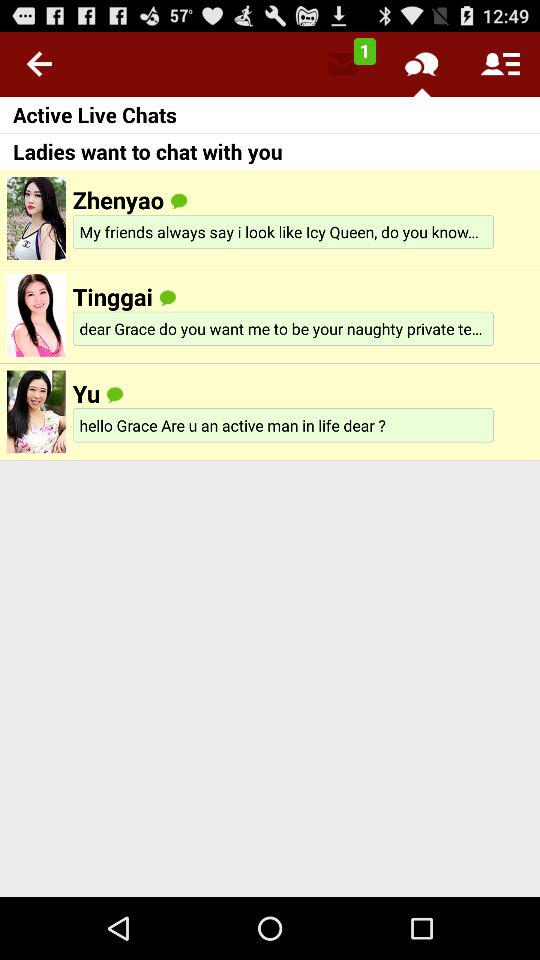How many unread messages are there? There is 1 unread message. 